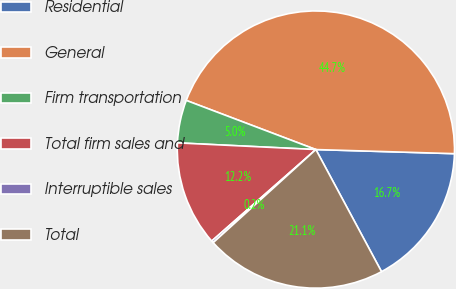Convert chart. <chart><loc_0><loc_0><loc_500><loc_500><pie_chart><fcel>Residential<fcel>General<fcel>Firm transportation<fcel>Total firm sales and<fcel>Interruptible sales<fcel>Total<nl><fcel>16.68%<fcel>44.71%<fcel>5.0%<fcel>12.24%<fcel>0.25%<fcel>21.13%<nl></chart> 